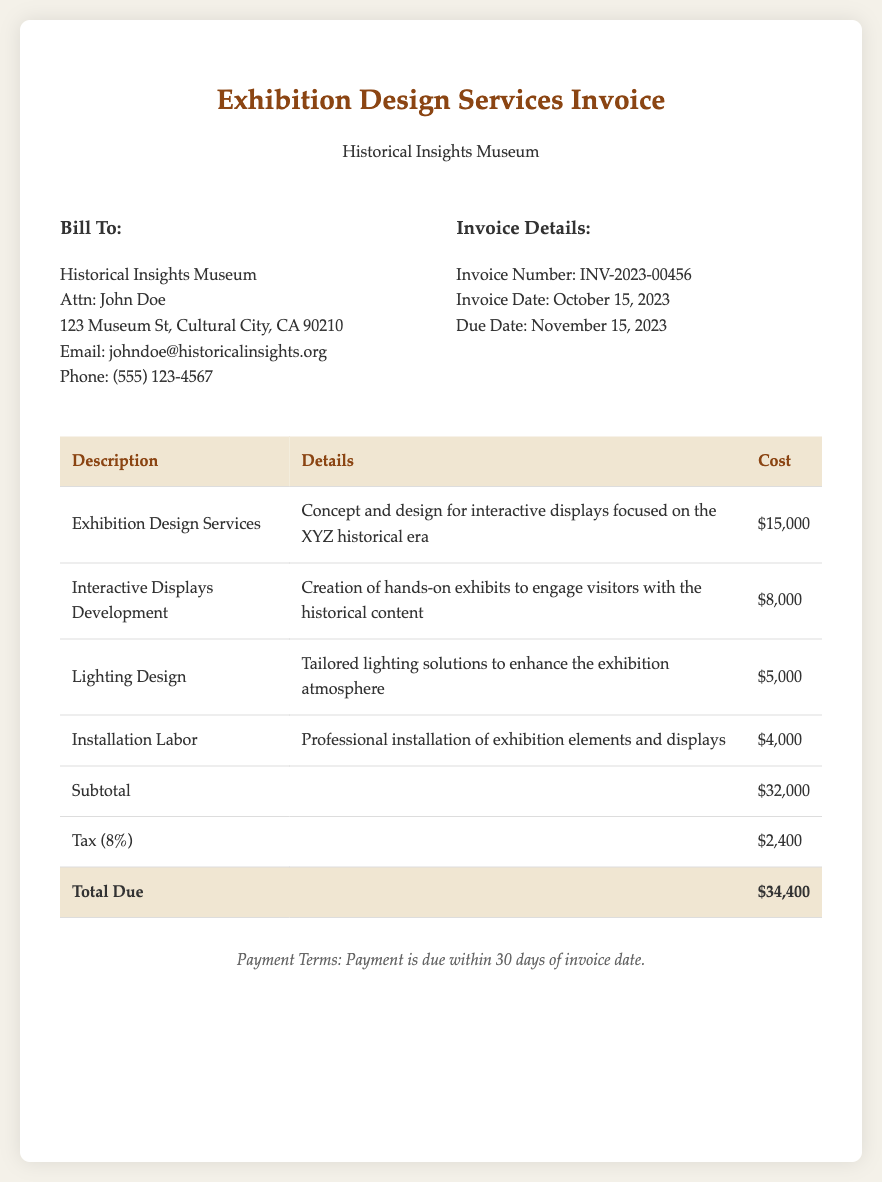What is the invoice number? The invoice number is specified in the document under the invoice details section.
Answer: INV-2023-00456 What is the total cost of interactive displays development? The cost for interactive displays development is listed in the table as a specific line item.
Answer: $8,000 When is the payment due? The due date for payment is provided in the invoice details section.
Answer: November 15, 2023 What is the subtotal amount before tax? The subtotal is calculated from the sum of all services listed before the tax is added.
Answer: $32,000 What is the tax percentage applied in the invoice? The applicable tax percentage is indicated in the tax line item of the invoice.
Answer: 8% What type of services does this invoice contain? The main services contained within the invoice involve exhibition design and development, as described in the header.
Answer: Exhibition Design Services How much is the total amount due? The total due is clearly stated in the total row of the invoice table.
Answer: $34,400 Who is the bill recipient? The recipient of the bill is detailed in the billing information section of the document.
Answer: Historical Insights Museum What is the invoice date? The invoice date is noted in the invoice details section.
Answer: October 15, 2023 